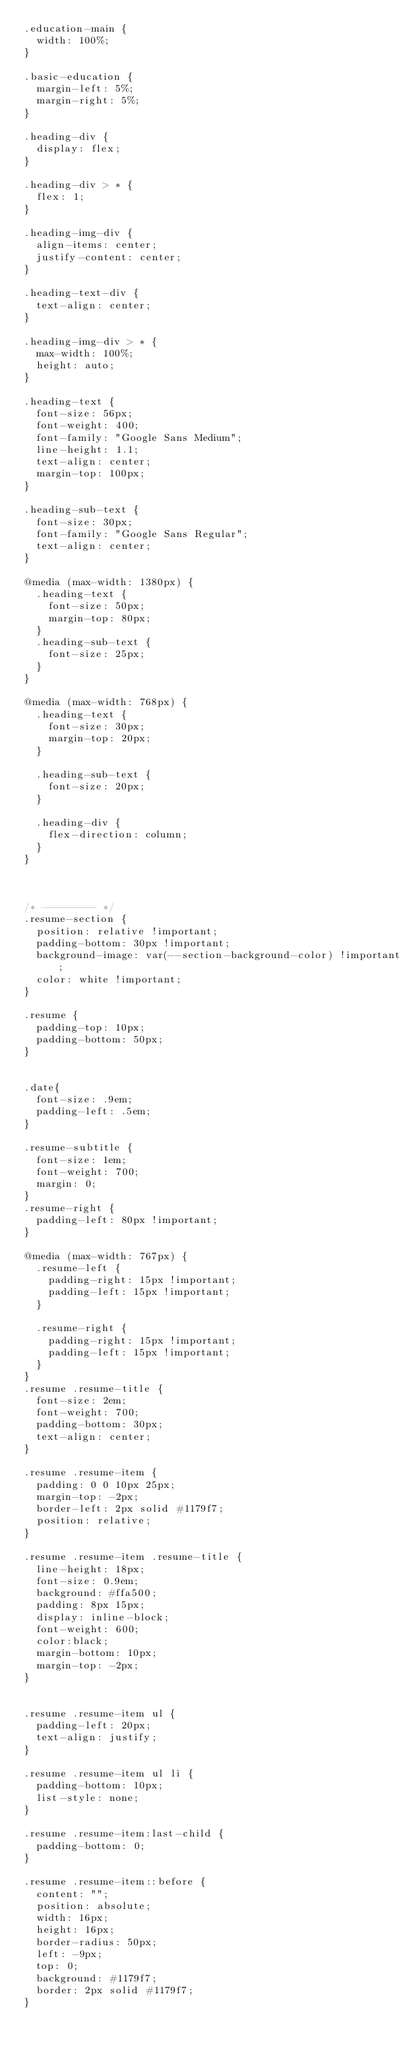<code> <loc_0><loc_0><loc_500><loc_500><_CSS_>.education-main {
  width: 100%;
}

.basic-education {
  margin-left: 5%;
  margin-right: 5%;
}

.heading-div {
  display: flex;
}

.heading-div > * {
  flex: 1;
}

.heading-img-div {
  align-items: center;
  justify-content: center;
}

.heading-text-div {
  text-align: center;
}

.heading-img-div > * {
  max-width: 100%;
  height: auto;
}

.heading-text {
  font-size: 56px;
  font-weight: 400;
  font-family: "Google Sans Medium";
  line-height: 1.1;
  text-align: center;
  margin-top: 100px;
}

.heading-sub-text {
  font-size: 30px;
  font-family: "Google Sans Regular";
  text-align: center;
}

@media (max-width: 1380px) {
  .heading-text {
    font-size: 50px;
    margin-top: 80px;
  }
  .heading-sub-text {
    font-size: 25px;
  }
}

@media (max-width: 768px) {
  .heading-text {
    font-size: 30px;
    margin-top: 20px;
  }

  .heading-sub-text {
    font-size: 20px;
  }

  .heading-div {
    flex-direction: column;
  }
}



/* --------- */
.resume-section {
  position: relative !important;
  padding-bottom: 30px !important;
  background-image: var(--section-background-color) !important;
  color: white !important;
}

.resume {
  padding-top: 10px;
  padding-bottom: 50px;
}


.date{
  font-size: .9em;
  padding-left: .5em;
}

.resume-subtitle {
  font-size: 1em;
  font-weight: 700;
  margin: 0;
} 
.resume-right {
  padding-left: 80px !important;
}

@media (max-width: 767px) {
  .resume-left {
    padding-right: 15px !important;
    padding-left: 15px !important;
  }

  .resume-right {
    padding-right: 15px !important;
    padding-left: 15px !important;
  }
}
.resume .resume-title {
  font-size: 2em;
  font-weight: 700;
  padding-bottom: 30px;
  text-align: center;
}

.resume .resume-item {
  padding: 0 0 10px 25px;
  margin-top: -2px;
  border-left: 2px solid #1179f7;
  position: relative;
}

.resume .resume-item .resume-title {
  line-height: 18px;
  font-size: 0.9em;
  background: #ffa500;
  padding: 8px 15px;
  display: inline-block;
  font-weight: 600;
  color:black;
  margin-bottom: 10px;
  margin-top: -2px;
}


.resume .resume-item ul {
  padding-left: 20px;
  text-align: justify;
}

.resume .resume-item ul li {
  padding-bottom: 10px;
  list-style: none;
}

.resume .resume-item:last-child {
  padding-bottom: 0;
}

.resume .resume-item::before {
  content: "";
  position: absolute;
  width: 16px;
  height: 16px;
  border-radius: 50px;
  left: -9px;
  top: 0;
  background: #1179f7;
  border: 2px solid #1179f7;
}</code> 